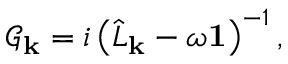<formula> <loc_0><loc_0><loc_500><loc_500>\mathcal { G } _ { k } = i \left ( \hat { L } _ { k } - \omega 1 \right ) ^ { - 1 } ,</formula> 